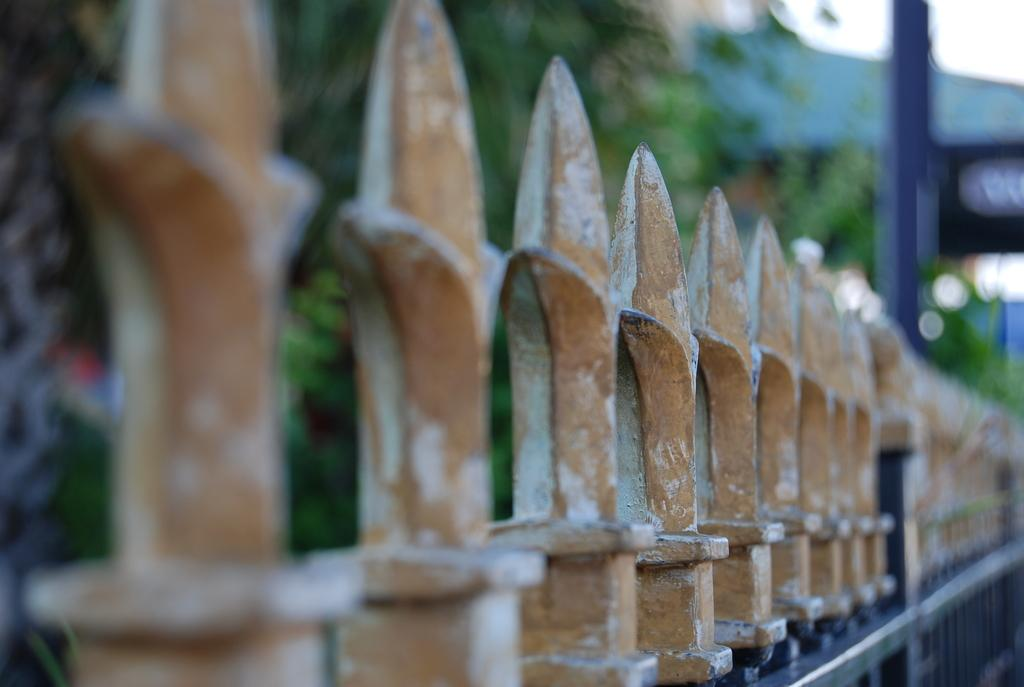What type of structure is located at the bottom of the image? There is an iron gate at the bottom of the image. What can be seen in the background of the image? There are trees in the background of the image. Is there a pin attached to the trees in the image? There is no pin present in the image; it only features an iron gate and trees in the background. 